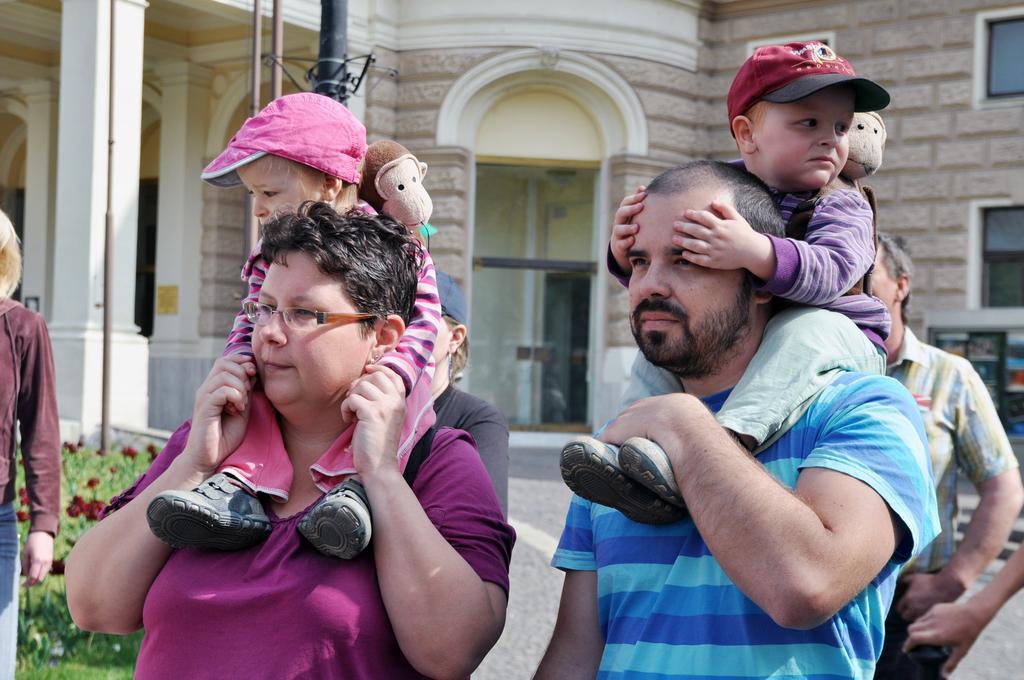How would you summarize this image in a sentence or two? In this image we can see there are two people carrying kids on their shoulders and those kids are wearing bags, behind them there is a group of people and in the background there is a house, pole and plants. 